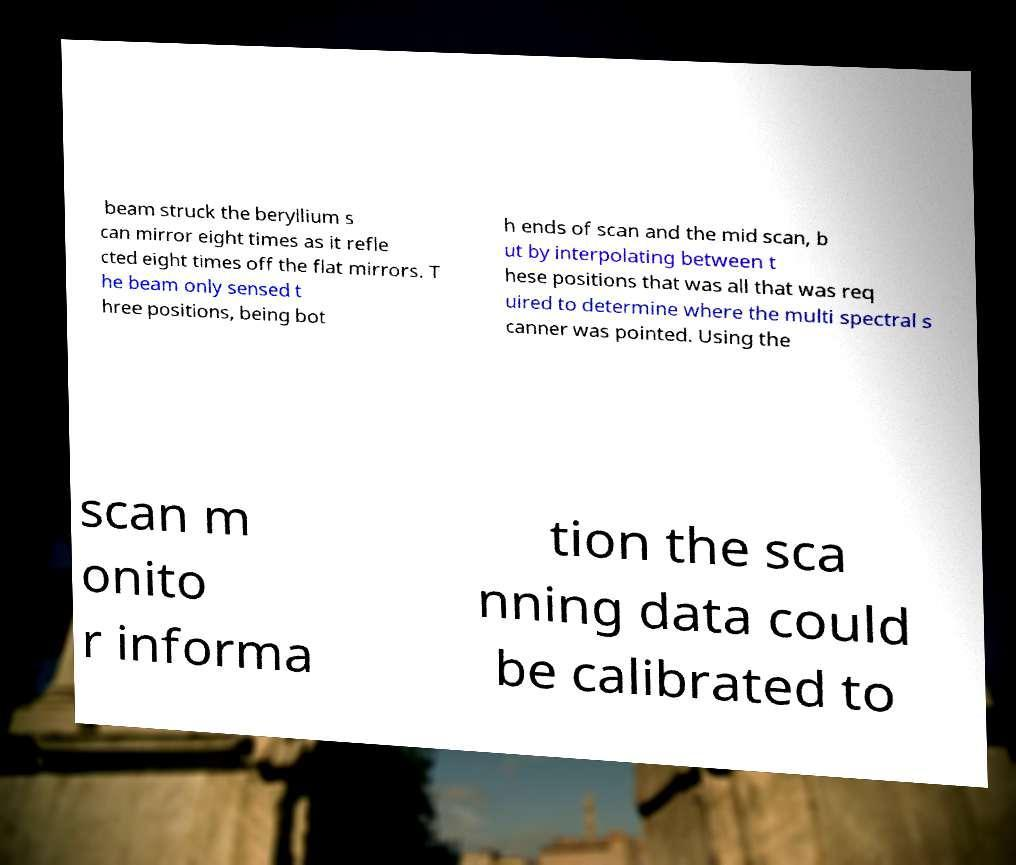Could you extract and type out the text from this image? beam struck the beryllium s can mirror eight times as it refle cted eight times off the flat mirrors. T he beam only sensed t hree positions, being bot h ends of scan and the mid scan, b ut by interpolating between t hese positions that was all that was req uired to determine where the multi spectral s canner was pointed. Using the scan m onito r informa tion the sca nning data could be calibrated to 